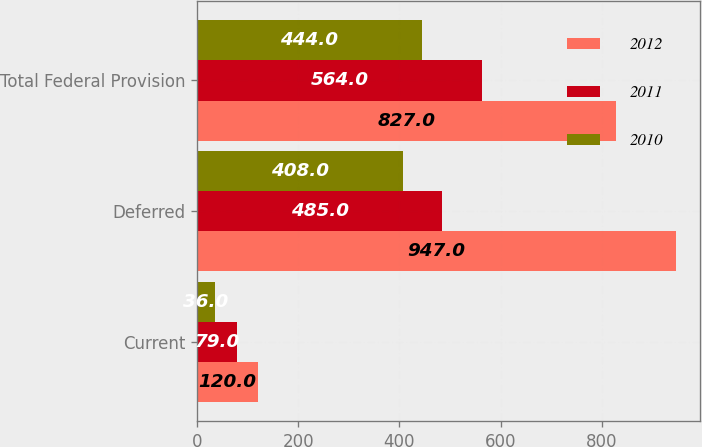Convert chart to OTSL. <chart><loc_0><loc_0><loc_500><loc_500><stacked_bar_chart><ecel><fcel>Current<fcel>Deferred<fcel>Total Federal Provision<nl><fcel>2012<fcel>120<fcel>947<fcel>827<nl><fcel>2011<fcel>79<fcel>485<fcel>564<nl><fcel>2010<fcel>36<fcel>408<fcel>444<nl></chart> 